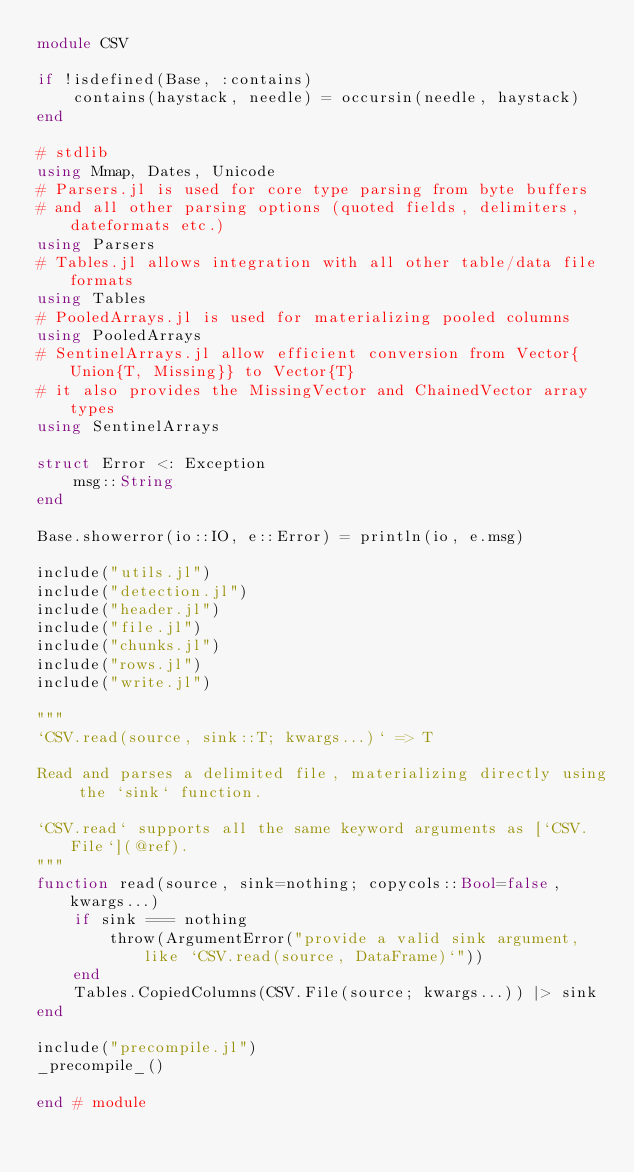Convert code to text. <code><loc_0><loc_0><loc_500><loc_500><_Julia_>module CSV

if !isdefined(Base, :contains)
    contains(haystack, needle) = occursin(needle, haystack)
end

# stdlib
using Mmap, Dates, Unicode
# Parsers.jl is used for core type parsing from byte buffers
# and all other parsing options (quoted fields, delimiters, dateformats etc.)
using Parsers
# Tables.jl allows integration with all other table/data file formats
using Tables
# PooledArrays.jl is used for materializing pooled columns
using PooledArrays
# SentinelArrays.jl allow efficient conversion from Vector{Union{T, Missing}} to Vector{T}
# it also provides the MissingVector and ChainedVector array types
using SentinelArrays

struct Error <: Exception
    msg::String
end

Base.showerror(io::IO, e::Error) = println(io, e.msg)

include("utils.jl")
include("detection.jl")
include("header.jl")
include("file.jl")
include("chunks.jl")
include("rows.jl")
include("write.jl")

"""
`CSV.read(source, sink::T; kwargs...)` => T

Read and parses a delimited file, materializing directly using the `sink` function.

`CSV.read` supports all the same keyword arguments as [`CSV.File`](@ref).
"""
function read(source, sink=nothing; copycols::Bool=false, kwargs...)
    if sink === nothing
        throw(ArgumentError("provide a valid sink argument, like `CSV.read(source, DataFrame)`"))
    end
    Tables.CopiedColumns(CSV.File(source; kwargs...)) |> sink
end

include("precompile.jl")
_precompile_()

end # module
</code> 